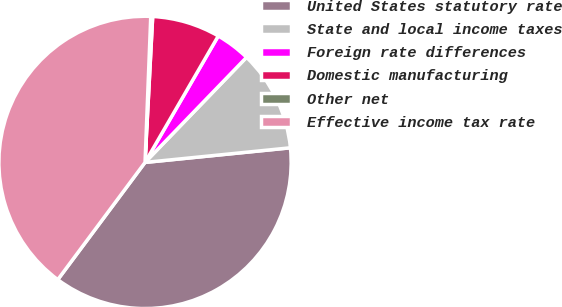<chart> <loc_0><loc_0><loc_500><loc_500><pie_chart><fcel>United States statutory rate<fcel>State and local income taxes<fcel>Foreign rate differences<fcel>Domestic manufacturing<fcel>Other net<fcel>Effective income tax rate<nl><fcel>36.78%<fcel>11.18%<fcel>3.87%<fcel>7.52%<fcel>0.21%<fcel>40.44%<nl></chart> 